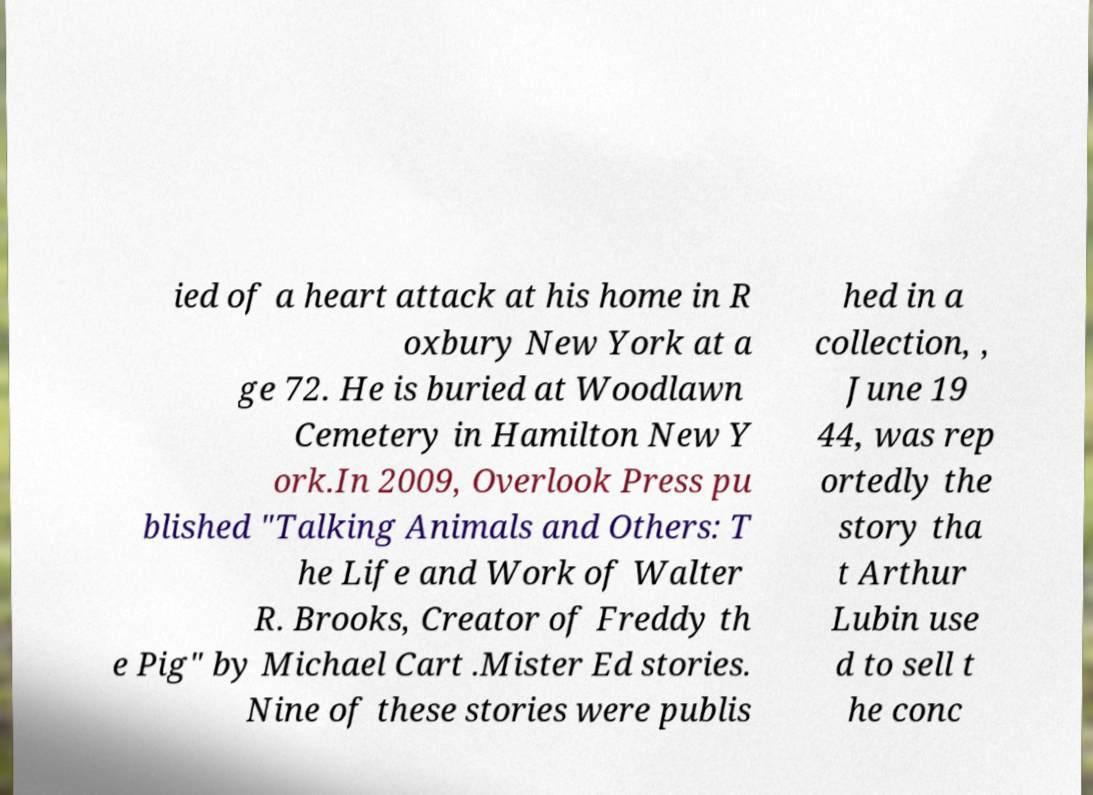There's text embedded in this image that I need extracted. Can you transcribe it verbatim? ied of a heart attack at his home in R oxbury New York at a ge 72. He is buried at Woodlawn Cemetery in Hamilton New Y ork.In 2009, Overlook Press pu blished "Talking Animals and Others: T he Life and Work of Walter R. Brooks, Creator of Freddy th e Pig" by Michael Cart .Mister Ed stories. Nine of these stories were publis hed in a collection, , June 19 44, was rep ortedly the story tha t Arthur Lubin use d to sell t he conc 